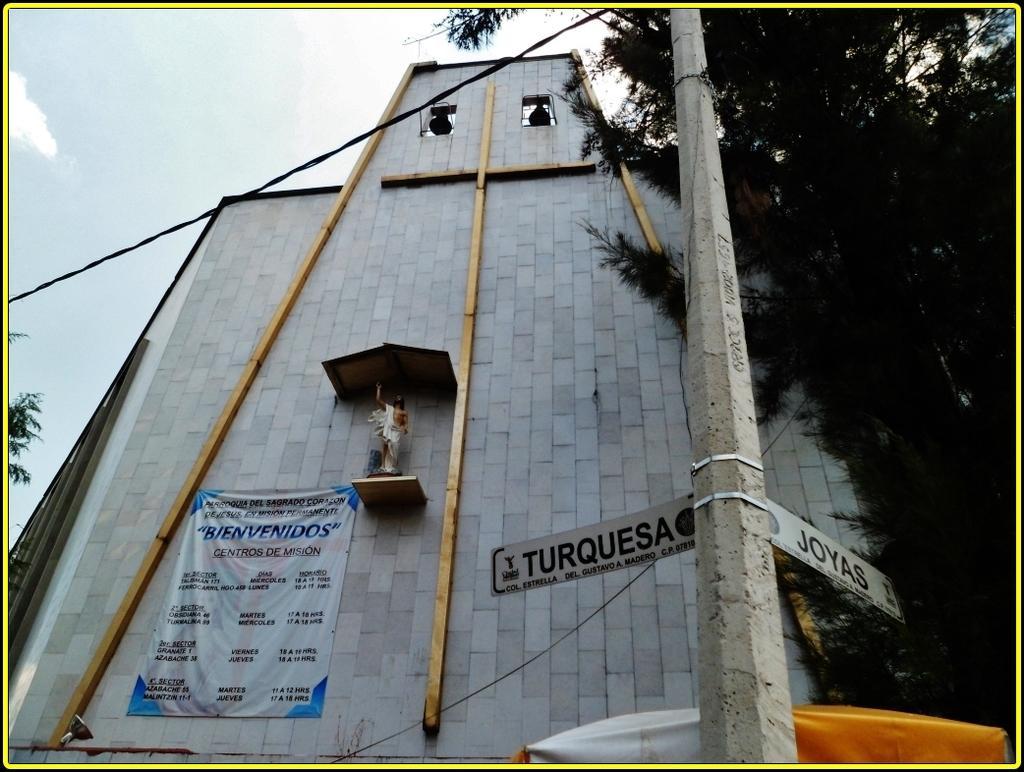How would you summarize this image in a sentence or two? In this image there is the sky truncated towards the top of the image, there are clouds in the sky, there are trees truncated towards the right of the image, there is a pole truncated, there are boards on the pole, there is text on the boards, there is a building truncated towards the bottom of the image, there is a banner in the building, there is text on the banner, there is a sculptor, there are bells, there is a wire truncated, there is an object truncated towards the bottom of the image, there is a tree truncated towards the left of the image, there is a light. 